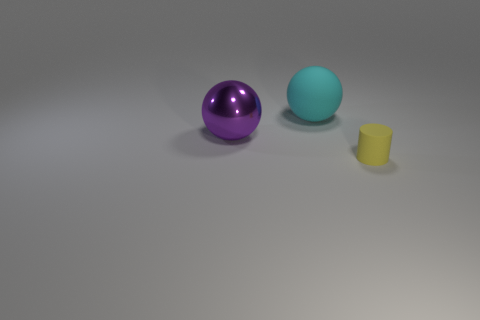What number of balls are either big blue objects or large cyan rubber things?
Your answer should be very brief. 1. There is another metal thing that is the same shape as the cyan thing; what is its size?
Ensure brevity in your answer.  Large. What number of yellow matte things are there?
Keep it short and to the point. 1. Do the yellow matte object and the rubber object behind the small yellow matte object have the same shape?
Offer a terse response. No. There is a rubber object in front of the big cyan thing; what size is it?
Provide a succinct answer. Small. What is the big cyan ball made of?
Ensure brevity in your answer.  Rubber. There is a matte thing left of the tiny yellow matte cylinder; is its shape the same as the yellow thing?
Ensure brevity in your answer.  No. Are there any purple metallic spheres that have the same size as the yellow rubber object?
Your answer should be compact. No. Are there any big cyan spheres that are in front of the sphere in front of the matte object left of the tiny yellow cylinder?
Keep it short and to the point. No. Is the color of the metallic thing the same as the rubber object behind the tiny yellow cylinder?
Ensure brevity in your answer.  No. 